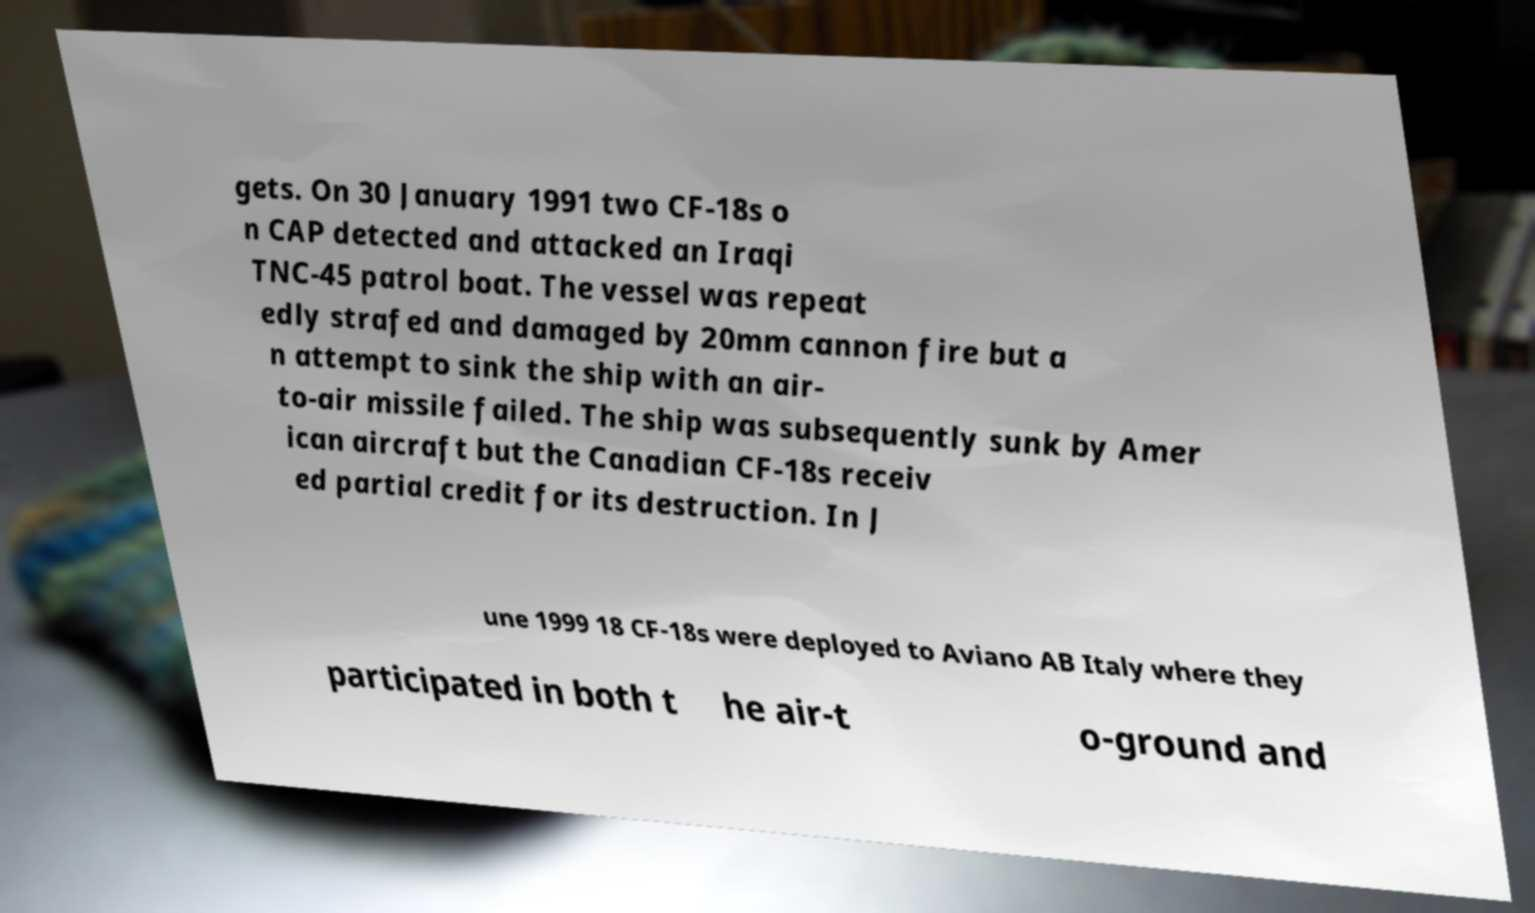Could you assist in decoding the text presented in this image and type it out clearly? gets. On 30 January 1991 two CF-18s o n CAP detected and attacked an Iraqi TNC-45 patrol boat. The vessel was repeat edly strafed and damaged by 20mm cannon fire but a n attempt to sink the ship with an air- to-air missile failed. The ship was subsequently sunk by Amer ican aircraft but the Canadian CF-18s receiv ed partial credit for its destruction. In J une 1999 18 CF-18s were deployed to Aviano AB Italy where they participated in both t he air-t o-ground and 